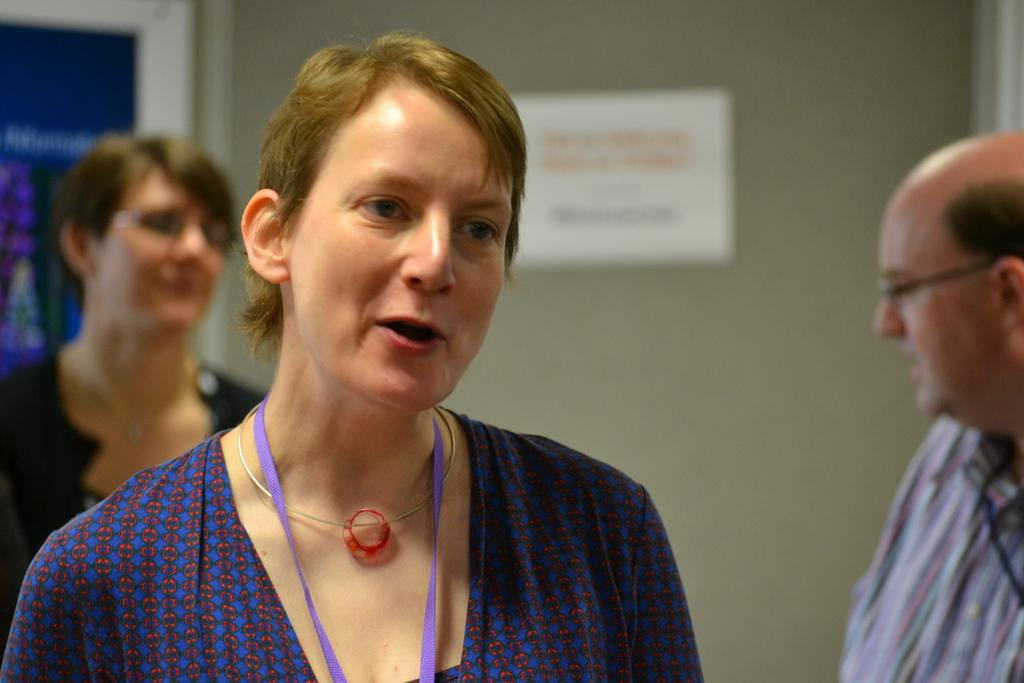How many people are present in the image? There are three persons in the image. What can be seen in the background of the image? There is a wall in the background of the image. Is there any paper or document visible in the image? Yes, there is a paper attached to the wall. What type of fence is on the right side of the image? There is a blue color fence on the right side of the image. What type of feast is being prepared by the persons in the image? There is no indication of a feast or any food preparation in the image. What type of underwear is visible on the persons in the image? There is no visible underwear on the persons in the image. 